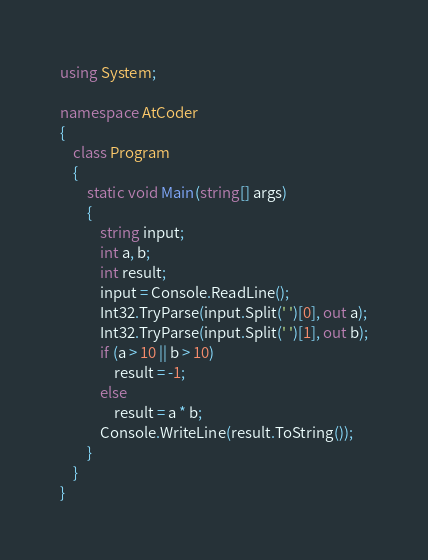<code> <loc_0><loc_0><loc_500><loc_500><_C#_>using System;

namespace AtCoder
{
    class Program
    {
        static void Main(string[] args)
        {
            string input;
            int a, b;
            int result;
            input = Console.ReadLine();
            Int32.TryParse(input.Split(' ')[0], out a);
            Int32.TryParse(input.Split(' ')[1], out b);
            if (a > 10 || b > 10)
                result = -1;
            else
                result = a * b;
            Console.WriteLine(result.ToString());
        }
    }
}
</code> 